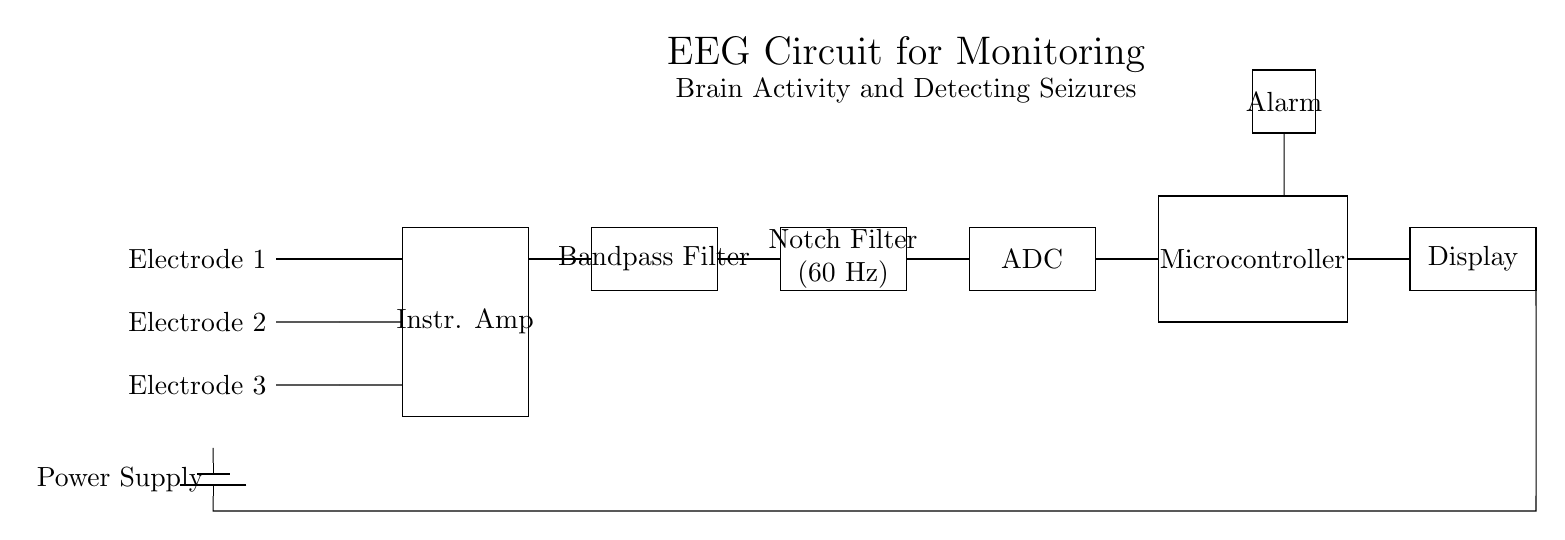What are the inputs to the instrumentation amplifier? The inputs to the instrumentation amplifier are from the three electrodes labeled Electrode 1, Electrode 2, and Electrode 3, which connect directly to it.
Answer: Electrode 1, Electrode 2, Electrode 3 What component is responsible for removing the 60 Hz noise? The component responsible for removing the 60 Hz noise is the notch filter, which is specifically designed to filter out this frequency from the EEG signals.
Answer: Notch Filter How many main functional blocks are in this circuit? The circuit contains five main functional blocks: Instrumentation Amplifier, Bandpass Filter, Notch Filter, ADC, and Microcontroller.
Answer: Five What does the ADC stand for? The abbreviation ADC stands for Analog-to-Digital Converter, which converts the analog EEG signals into digital form for further processing.
Answer: Analog-to-Digital Converter Why is a bandpass filter used in the EEG circuit? A bandpass filter is used to ensure that only the relevant frequencies related to brain activity are passed through while filtering out other unwanted frequencies, thereby enhancing the quality of the EEG signal.
Answer: To isolate relevant frequencies What is the role of the display in this circuit? The display provides a visual output of the processed brain activity data captured by the EEG circuit, allowing for real-time monitoring.
Answer: Visual output 